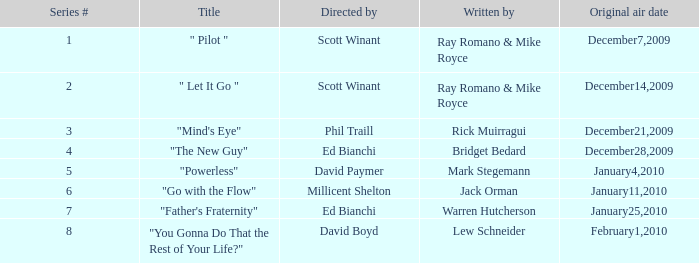Can you give me this table as a dict? {'header': ['Series #', 'Title', 'Directed by', 'Written by', 'Original air date'], 'rows': [['1', '" Pilot "', 'Scott Winant', 'Ray Romano & Mike Royce', 'December7,2009'], ['2', '" Let It Go "', 'Scott Winant', 'Ray Romano & Mike Royce', 'December14,2009'], ['3', '"Mind\'s Eye"', 'Phil Traill', 'Rick Muirragui', 'December21,2009'], ['4', '"The New Guy"', 'Ed Bianchi', 'Bridget Bedard', 'December28,2009'], ['5', '"Powerless"', 'David Paymer', 'Mark Stegemann', 'January4,2010'], ['6', '"Go with the Flow"', 'Millicent Shelton', 'Jack Orman', 'January11,2010'], ['7', '"Father\'s Fraternity"', 'Ed Bianchi', 'Warren Hutcherson', 'January25,2010'], ['8', '"You Gonna Do That the Rest of Your Life?"', 'David Boyd', 'Lew Schneider', 'February1,2010']]} What is the episode number of  "you gonna do that the rest of your life?" 8.0. 